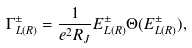<formula> <loc_0><loc_0><loc_500><loc_500>\Gamma ^ { \pm } _ { L ( R ) } = \frac { 1 } { e ^ { 2 } R _ { J } } E ^ { \pm } _ { L ( R ) } \Theta ( E ^ { \pm } _ { L ( R ) } ) ,</formula> 